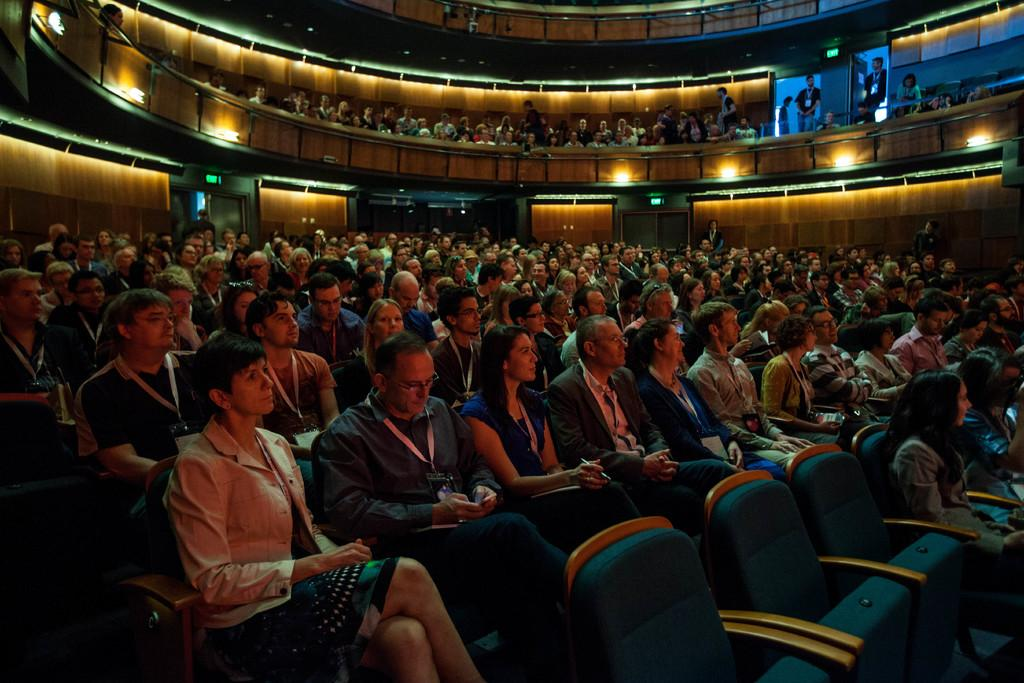What is the main subject of the image? The main subject of the image is a group of people. How are the people arranged in the image? The people are sitting in an order. Are there any people sitting at a higher level in the image? Yes, there are people sitting on top in the image. What type of button can be seen on the quince in the image? There is no button or quince present in the image; it features a group of people sitting in an order. 